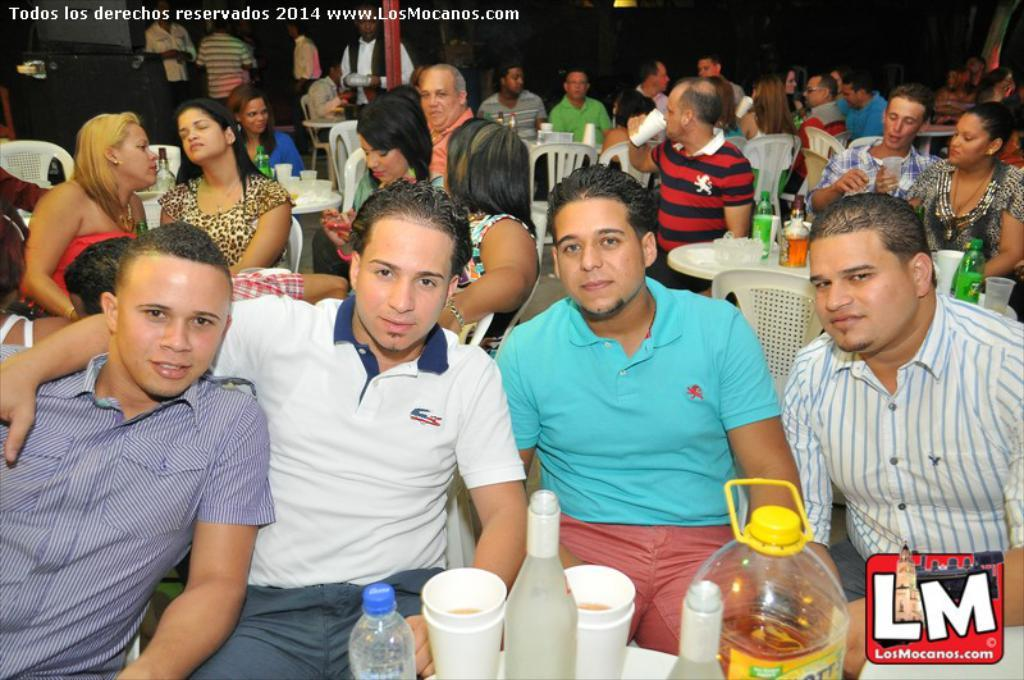What is happening in the image? There is a group of people sitting in front of a table. What objects are on the table? There are bottles and cups on the table. Can you describe the people in the background? In the background, some people are standing. What types of toys can be seen on the edge of the table? There are no toys present in the image; it features a group of people sitting in front of a table with bottles and cups. What group of people is responsible for organizing the event in the image? The image does not provide information about who organized the event or any specific group of people. 